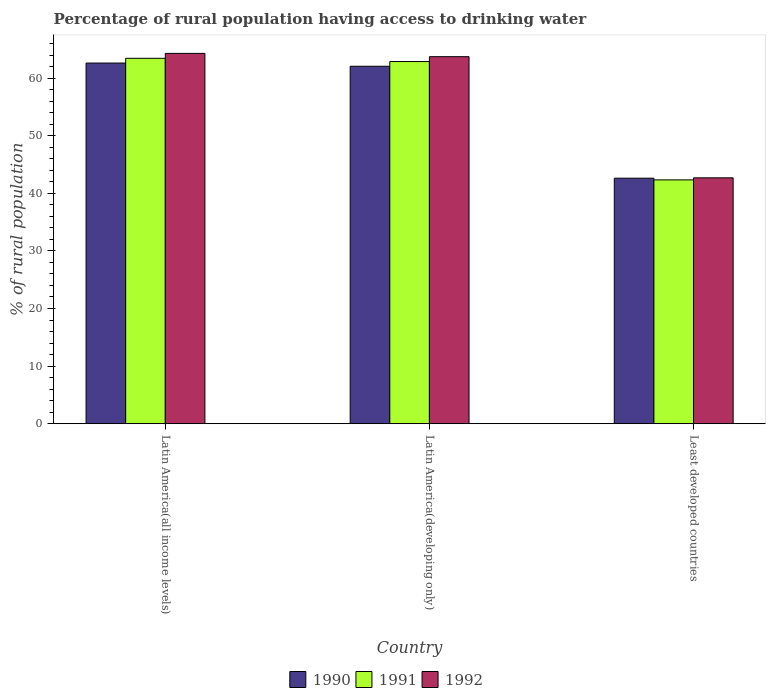How many different coloured bars are there?
Keep it short and to the point. 3. How many groups of bars are there?
Provide a short and direct response. 3. How many bars are there on the 2nd tick from the left?
Give a very brief answer. 3. How many bars are there on the 3rd tick from the right?
Provide a succinct answer. 3. What is the label of the 3rd group of bars from the left?
Give a very brief answer. Least developed countries. What is the percentage of rural population having access to drinking water in 1992 in Least developed countries?
Offer a terse response. 42.68. Across all countries, what is the maximum percentage of rural population having access to drinking water in 1991?
Offer a terse response. 63.43. Across all countries, what is the minimum percentage of rural population having access to drinking water in 1991?
Ensure brevity in your answer.  42.33. In which country was the percentage of rural population having access to drinking water in 1991 maximum?
Provide a short and direct response. Latin America(all income levels). In which country was the percentage of rural population having access to drinking water in 1991 minimum?
Your answer should be very brief. Least developed countries. What is the total percentage of rural population having access to drinking water in 1990 in the graph?
Provide a succinct answer. 167.28. What is the difference between the percentage of rural population having access to drinking water in 1990 in Latin America(developing only) and that in Least developed countries?
Offer a terse response. 19.43. What is the difference between the percentage of rural population having access to drinking water in 1990 in Least developed countries and the percentage of rural population having access to drinking water in 1991 in Latin America(developing only)?
Your answer should be very brief. -20.25. What is the average percentage of rural population having access to drinking water in 1992 per country?
Your answer should be very brief. 56.89. What is the difference between the percentage of rural population having access to drinking water of/in 1991 and percentage of rural population having access to drinking water of/in 1990 in Latin America(developing only)?
Provide a short and direct response. 0.82. In how many countries, is the percentage of rural population having access to drinking water in 1991 greater than 30 %?
Keep it short and to the point. 3. What is the ratio of the percentage of rural population having access to drinking water in 1990 in Latin America(developing only) to that in Least developed countries?
Offer a terse response. 1.46. Is the difference between the percentage of rural population having access to drinking water in 1991 in Latin America(all income levels) and Latin America(developing only) greater than the difference between the percentage of rural population having access to drinking water in 1990 in Latin America(all income levels) and Latin America(developing only)?
Your answer should be very brief. Yes. What is the difference between the highest and the second highest percentage of rural population having access to drinking water in 1992?
Offer a terse response. 21.6. What is the difference between the highest and the lowest percentage of rural population having access to drinking water in 1992?
Your response must be concise. 21.6. In how many countries, is the percentage of rural population having access to drinking water in 1990 greater than the average percentage of rural population having access to drinking water in 1990 taken over all countries?
Your answer should be compact. 2. What does the 1st bar from the right in Latin America(developing only) represents?
Give a very brief answer. 1992. Is it the case that in every country, the sum of the percentage of rural population having access to drinking water in 1992 and percentage of rural population having access to drinking water in 1990 is greater than the percentage of rural population having access to drinking water in 1991?
Your response must be concise. Yes. Are all the bars in the graph horizontal?
Provide a succinct answer. No. Does the graph contain any zero values?
Your answer should be compact. No. Does the graph contain grids?
Give a very brief answer. No. Where does the legend appear in the graph?
Provide a succinct answer. Bottom center. How many legend labels are there?
Offer a very short reply. 3. What is the title of the graph?
Make the answer very short. Percentage of rural population having access to drinking water. Does "1983" appear as one of the legend labels in the graph?
Make the answer very short. No. What is the label or title of the X-axis?
Offer a very short reply. Country. What is the label or title of the Y-axis?
Ensure brevity in your answer.  % of rural population. What is the % of rural population of 1990 in Latin America(all income levels)?
Your response must be concise. 62.61. What is the % of rural population of 1991 in Latin America(all income levels)?
Ensure brevity in your answer.  63.43. What is the % of rural population in 1992 in Latin America(all income levels)?
Your answer should be very brief. 64.28. What is the % of rural population of 1990 in Latin America(developing only)?
Ensure brevity in your answer.  62.05. What is the % of rural population of 1991 in Latin America(developing only)?
Your response must be concise. 62.87. What is the % of rural population in 1992 in Latin America(developing only)?
Your answer should be very brief. 63.71. What is the % of rural population of 1990 in Least developed countries?
Your answer should be compact. 42.62. What is the % of rural population in 1991 in Least developed countries?
Your response must be concise. 42.33. What is the % of rural population of 1992 in Least developed countries?
Provide a short and direct response. 42.68. Across all countries, what is the maximum % of rural population of 1990?
Ensure brevity in your answer.  62.61. Across all countries, what is the maximum % of rural population in 1991?
Your answer should be compact. 63.43. Across all countries, what is the maximum % of rural population of 1992?
Your answer should be compact. 64.28. Across all countries, what is the minimum % of rural population of 1990?
Your answer should be very brief. 42.62. Across all countries, what is the minimum % of rural population of 1991?
Offer a very short reply. 42.33. Across all countries, what is the minimum % of rural population of 1992?
Your answer should be very brief. 42.68. What is the total % of rural population in 1990 in the graph?
Provide a succinct answer. 167.28. What is the total % of rural population of 1991 in the graph?
Your answer should be compact. 168.63. What is the total % of rural population in 1992 in the graph?
Keep it short and to the point. 170.68. What is the difference between the % of rural population in 1990 in Latin America(all income levels) and that in Latin America(developing only)?
Offer a terse response. 0.56. What is the difference between the % of rural population of 1991 in Latin America(all income levels) and that in Latin America(developing only)?
Your answer should be very brief. 0.56. What is the difference between the % of rural population in 1990 in Latin America(all income levels) and that in Least developed countries?
Offer a very short reply. 19.99. What is the difference between the % of rural population in 1991 in Latin America(all income levels) and that in Least developed countries?
Your answer should be very brief. 21.11. What is the difference between the % of rural population in 1992 in Latin America(all income levels) and that in Least developed countries?
Provide a short and direct response. 21.6. What is the difference between the % of rural population of 1990 in Latin America(developing only) and that in Least developed countries?
Your answer should be very brief. 19.43. What is the difference between the % of rural population of 1991 in Latin America(developing only) and that in Least developed countries?
Keep it short and to the point. 20.54. What is the difference between the % of rural population in 1992 in Latin America(developing only) and that in Least developed countries?
Provide a short and direct response. 21.03. What is the difference between the % of rural population in 1990 in Latin America(all income levels) and the % of rural population in 1991 in Latin America(developing only)?
Your answer should be compact. -0.26. What is the difference between the % of rural population of 1990 in Latin America(all income levels) and the % of rural population of 1992 in Latin America(developing only)?
Your answer should be very brief. -1.11. What is the difference between the % of rural population of 1991 in Latin America(all income levels) and the % of rural population of 1992 in Latin America(developing only)?
Provide a short and direct response. -0.28. What is the difference between the % of rural population of 1990 in Latin America(all income levels) and the % of rural population of 1991 in Least developed countries?
Keep it short and to the point. 20.28. What is the difference between the % of rural population of 1990 in Latin America(all income levels) and the % of rural population of 1992 in Least developed countries?
Offer a terse response. 19.92. What is the difference between the % of rural population in 1991 in Latin America(all income levels) and the % of rural population in 1992 in Least developed countries?
Offer a terse response. 20.75. What is the difference between the % of rural population in 1990 in Latin America(developing only) and the % of rural population in 1991 in Least developed countries?
Offer a very short reply. 19.72. What is the difference between the % of rural population of 1990 in Latin America(developing only) and the % of rural population of 1992 in Least developed countries?
Your response must be concise. 19.37. What is the difference between the % of rural population of 1991 in Latin America(developing only) and the % of rural population of 1992 in Least developed countries?
Your answer should be very brief. 20.19. What is the average % of rural population of 1990 per country?
Give a very brief answer. 55.76. What is the average % of rural population of 1991 per country?
Ensure brevity in your answer.  56.21. What is the average % of rural population of 1992 per country?
Provide a succinct answer. 56.89. What is the difference between the % of rural population of 1990 and % of rural population of 1991 in Latin America(all income levels)?
Your answer should be very brief. -0.83. What is the difference between the % of rural population of 1990 and % of rural population of 1992 in Latin America(all income levels)?
Your answer should be compact. -1.68. What is the difference between the % of rural population of 1991 and % of rural population of 1992 in Latin America(all income levels)?
Provide a succinct answer. -0.85. What is the difference between the % of rural population of 1990 and % of rural population of 1991 in Latin America(developing only)?
Offer a very short reply. -0.82. What is the difference between the % of rural population in 1990 and % of rural population in 1992 in Latin America(developing only)?
Your response must be concise. -1.66. What is the difference between the % of rural population of 1991 and % of rural population of 1992 in Latin America(developing only)?
Provide a short and direct response. -0.84. What is the difference between the % of rural population of 1990 and % of rural population of 1991 in Least developed countries?
Give a very brief answer. 0.29. What is the difference between the % of rural population of 1990 and % of rural population of 1992 in Least developed countries?
Your response must be concise. -0.06. What is the difference between the % of rural population of 1991 and % of rural population of 1992 in Least developed countries?
Offer a very short reply. -0.36. What is the ratio of the % of rural population in 1992 in Latin America(all income levels) to that in Latin America(developing only)?
Offer a very short reply. 1.01. What is the ratio of the % of rural population in 1990 in Latin America(all income levels) to that in Least developed countries?
Offer a terse response. 1.47. What is the ratio of the % of rural population in 1991 in Latin America(all income levels) to that in Least developed countries?
Your answer should be compact. 1.5. What is the ratio of the % of rural population of 1992 in Latin America(all income levels) to that in Least developed countries?
Keep it short and to the point. 1.51. What is the ratio of the % of rural population in 1990 in Latin America(developing only) to that in Least developed countries?
Make the answer very short. 1.46. What is the ratio of the % of rural population in 1991 in Latin America(developing only) to that in Least developed countries?
Provide a succinct answer. 1.49. What is the ratio of the % of rural population of 1992 in Latin America(developing only) to that in Least developed countries?
Your response must be concise. 1.49. What is the difference between the highest and the second highest % of rural population in 1990?
Ensure brevity in your answer.  0.56. What is the difference between the highest and the second highest % of rural population of 1991?
Provide a short and direct response. 0.56. What is the difference between the highest and the second highest % of rural population in 1992?
Your response must be concise. 0.57. What is the difference between the highest and the lowest % of rural population of 1990?
Give a very brief answer. 19.99. What is the difference between the highest and the lowest % of rural population in 1991?
Provide a short and direct response. 21.11. What is the difference between the highest and the lowest % of rural population in 1992?
Your answer should be compact. 21.6. 